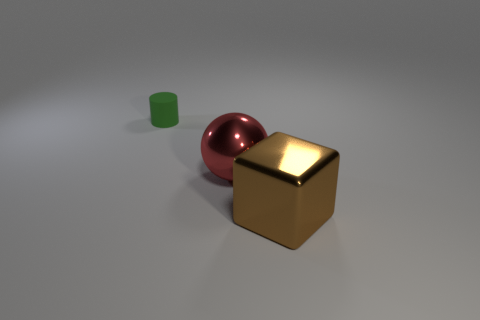Add 3 green rubber objects. How many objects exist? 6 Subtract all cylinders. How many objects are left? 2 Add 2 big brown blocks. How many big brown blocks exist? 3 Subtract 1 brown blocks. How many objects are left? 2 Subtract all green matte cylinders. Subtract all red metal spheres. How many objects are left? 1 Add 3 brown metallic things. How many brown metallic things are left? 4 